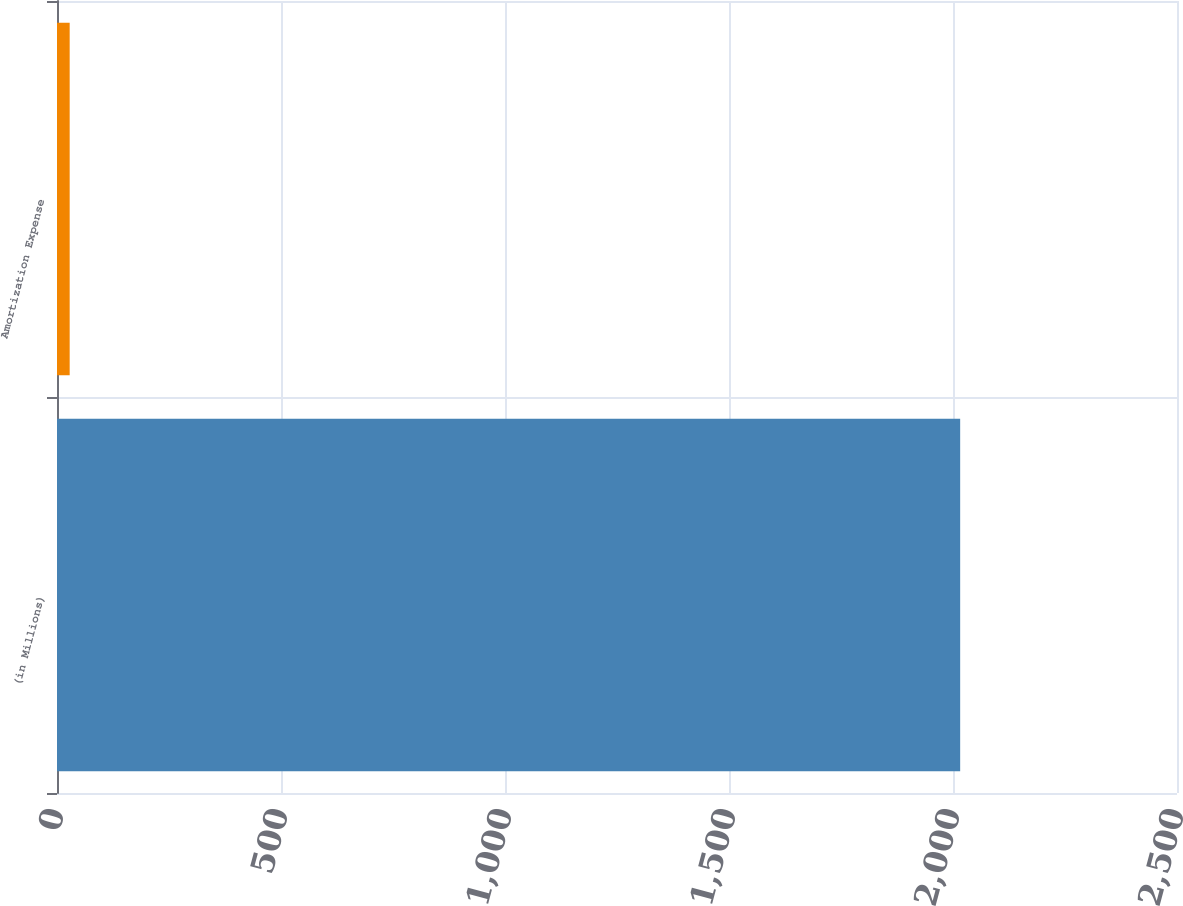<chart> <loc_0><loc_0><loc_500><loc_500><bar_chart><fcel>(in Millions)<fcel>Amortization Expense<nl><fcel>2016<fcel>28.3<nl></chart> 